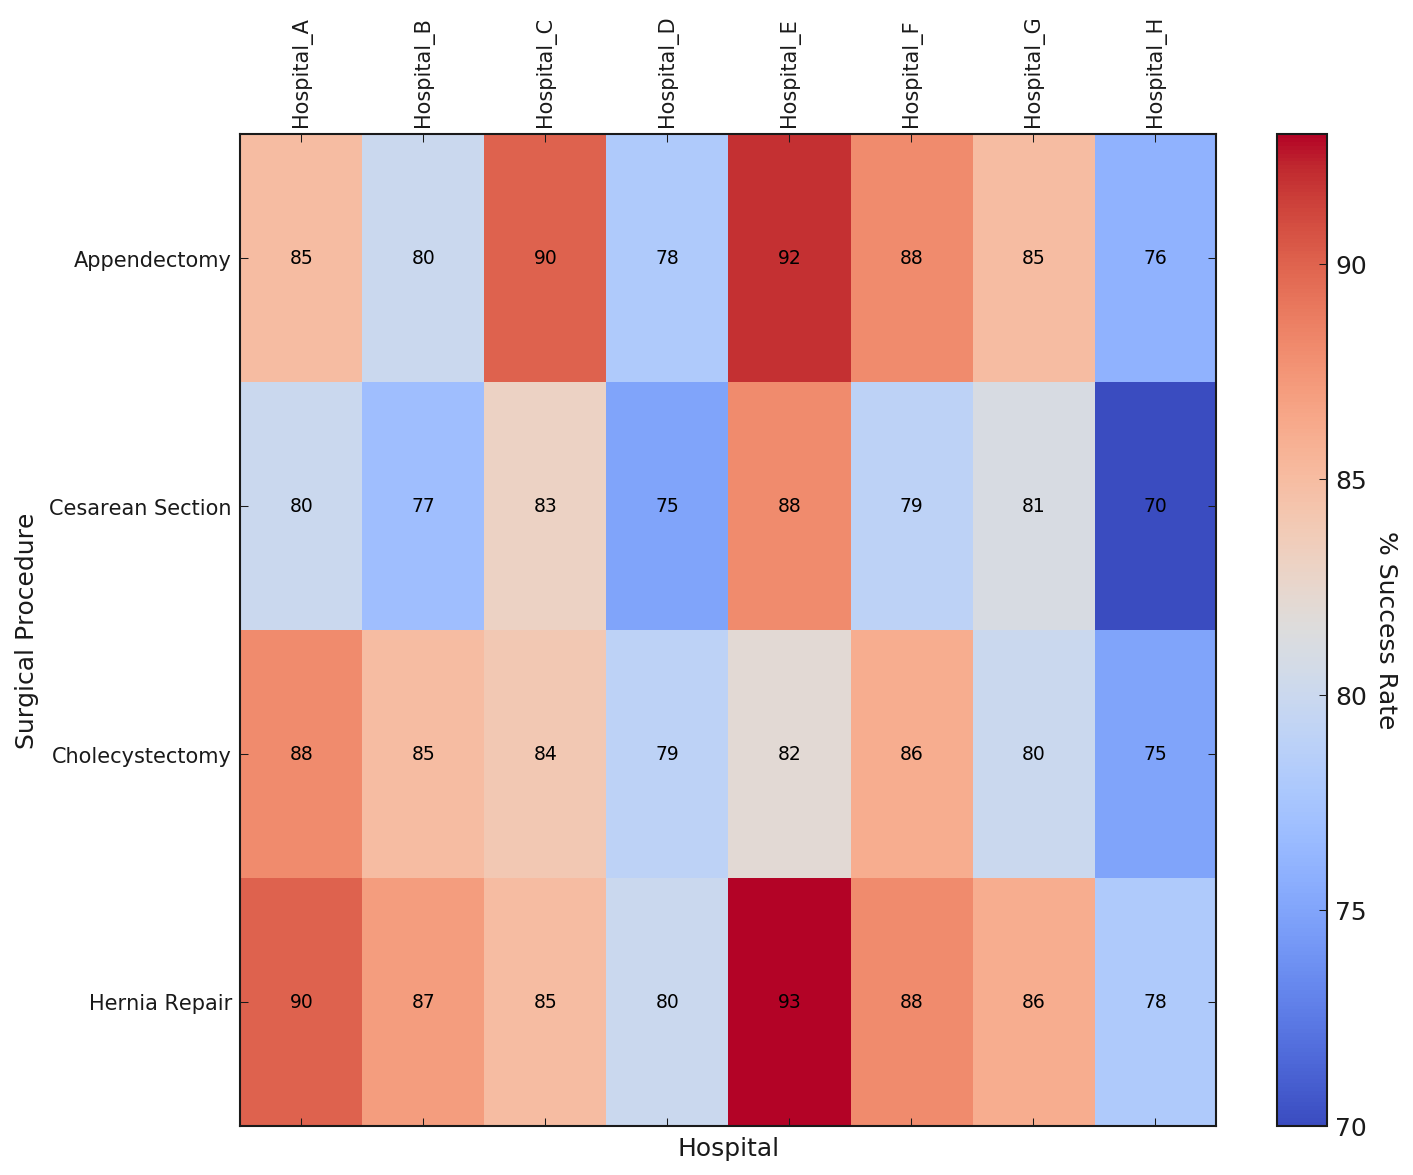What is the success rate for an appendectomy in Hospital E? To find this, locate the intersection of the row for "Appendectomy" and the column for "Hospital E" in the heatmap. The value at this intersection represents the success rate.
Answer: 92 Which hospital has the highest success rate for cesarean sections? Identify the row for "Cesarean Section" and then find the highest value by scanning across the row. Note the corresponding hospital at the top of this value.
Answer: Hospital E By how much does the success rate for hernia repair at Hospital H differ from the rate at Hospital C? Locate the success rate for hernia repair in both Hospital H and Hospital C. Subtract the value for Hospital H (78) from the value for Hospital C (85).
Answer: 7 Which hospital has the lowest overall average success rate across all procedures? Calculate the average success rate for each hospital by averaging the rates for all procedures. Compare these averages to identify the lowest one.
Answer: Hospital H Considering cholecystectomy procedure, which hospital has the closest success rate to 85%? Find the success rate for "Cholecystectomy" across all hospitals and identify the one whose rate is closest to 85%. Compare Hospital B (85) and Hospital C (84).
Answer: Hospital B What is the average success rate for appendectomy procedures across all hospitals? Add up the success rates for the "Appendectomy" row, then divide by the number of hospitals (8). The rates are 85, 80, 90, 78, 92, 88, 85, 76. (85+80+90+78+92+88+85+76)/8 = 83.
Answer: 84 What is the difference in the success rate for cholecystectomy between hospitals with the highest and lowest rates? Locate the maximum and minimum values for the "Cholecystectomy" row. The highest is Hospital A (88) and the lowest is Hospital H (75). Subtract the minimum from the maximum (88-75).
Answer: 13 What color corresponds to the highest success rates? Identify the color represented in the heatmap for the highest success rates (90 and above). The corresponding color in a 'coolwarm' heatmap is usually towards the red end.
Answer: Red Which hospitals have success rates below 80% for cesarean sections? Look at the "Cesarean Section" row and identify all columns that have values less than 80%. These columns correspond to the hospitals.
Answer: Hospital B, Hospital D, Hospital F, Hospital H What is the range of success rates for hernia repair across all hospitals? Identify the minimum and maximum values for the "Hernia Repair" row. The minimum is 78 (Hospital H) and the maximum is 93 (Hospital E). Subtract the minimum from the maximum (93-78).
Answer: 15 